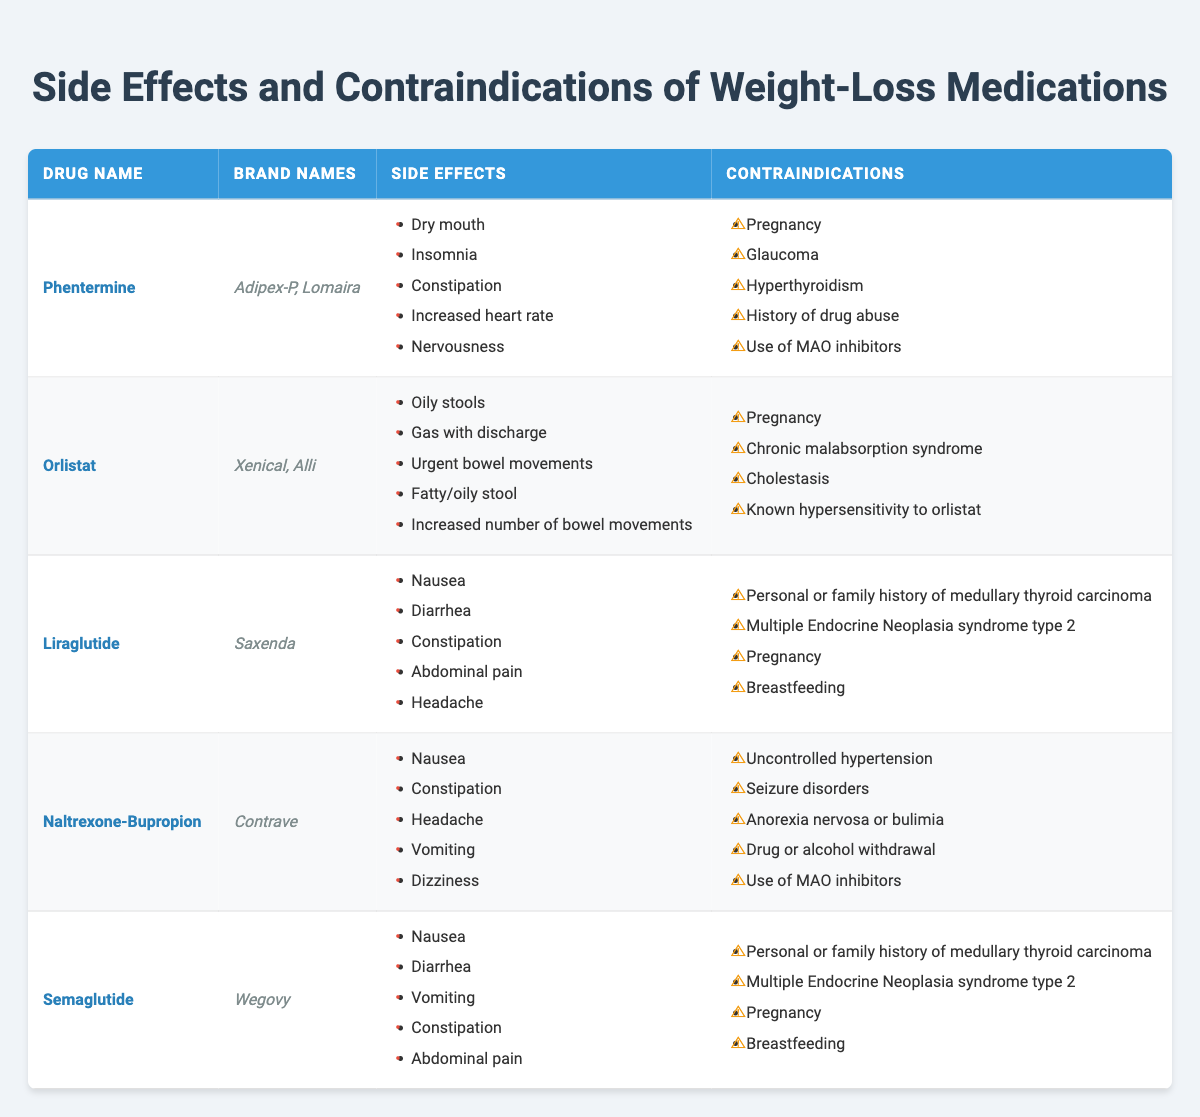What are the brand names for Orlistat? The table lists "Xenical" and "Alli" as the brand names for Orlistat.
Answer: Xenical, Alli Which drug has the highest number of side effects? Looking at the table, both Phentermine and Naltrexone-Bupropion have 5 side effects, which is the highest among the listed drugs.
Answer: Phentermine and Naltrexone-Bupropion Does Semaglutide have any contraindications related to thyroid cancer? Yes, the table indicates that both Semaglutide and Liraglutide have contraindications for personal or family history of medullary thyroid carcinoma.
Answer: Yes How many side effects does Naltrexone-Bupropion have compared to Orlistat? Naltrexone-Bupropion has 5 side effects while Orlistat has 5 side effects as well, meaning they have the same number of side effects.
Answer: Same (5 each) Are there any contraindications that overlap between Liraglutide and Semaglutide? Yes, both Liraglutide and Semaglutide share the same contraindications: personal or family history of medullary thyroid carcinoma and Multiple Endocrine Neoplasia syndrome type 2.
Answer: Yes Which drug has a contraindication for uncontrolled hypertension? According to the table, Naltrexone-Bupropion has a contraindication for uncontrolled hypertension, while the other drugs do not list this condition.
Answer: Naltrexone-Bupropion What is the total number of contraindications listed across all medications? Counting the contraindications from all medications, there are a total of 22 different contraindications, but some may overlap between drugs.
Answer: 22 Is there a weight-loss medication that is prohibited for breastfeeding? Both Liraglutide and Semaglutide are contraindicated in breastfeeding, according to the table.
Answer: Yes How many side effects does Phentermine share with Naltrexone-Bupropion? Comparing the side effects, Phentermine and Naltrexone-Bupropion share 2 common side effects: Nausea and Constipation.
Answer: 2 Which medication has the least number of side effects listed? Liraglutide has 5 side effects listed, the same as others, but doesn’t include oily or gas-related issues as seen in Orlistat. The fewest mentions of unique effects could suggest it's less irritating overall. However, they all have similar range at 5.
Answer: All have 5 